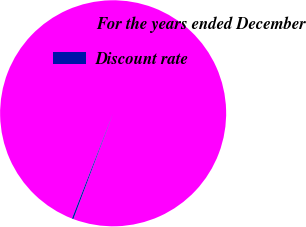Convert chart to OTSL. <chart><loc_0><loc_0><loc_500><loc_500><pie_chart><fcel>For the years ended December<fcel>Discount rate<nl><fcel>99.78%<fcel>0.22%<nl></chart> 